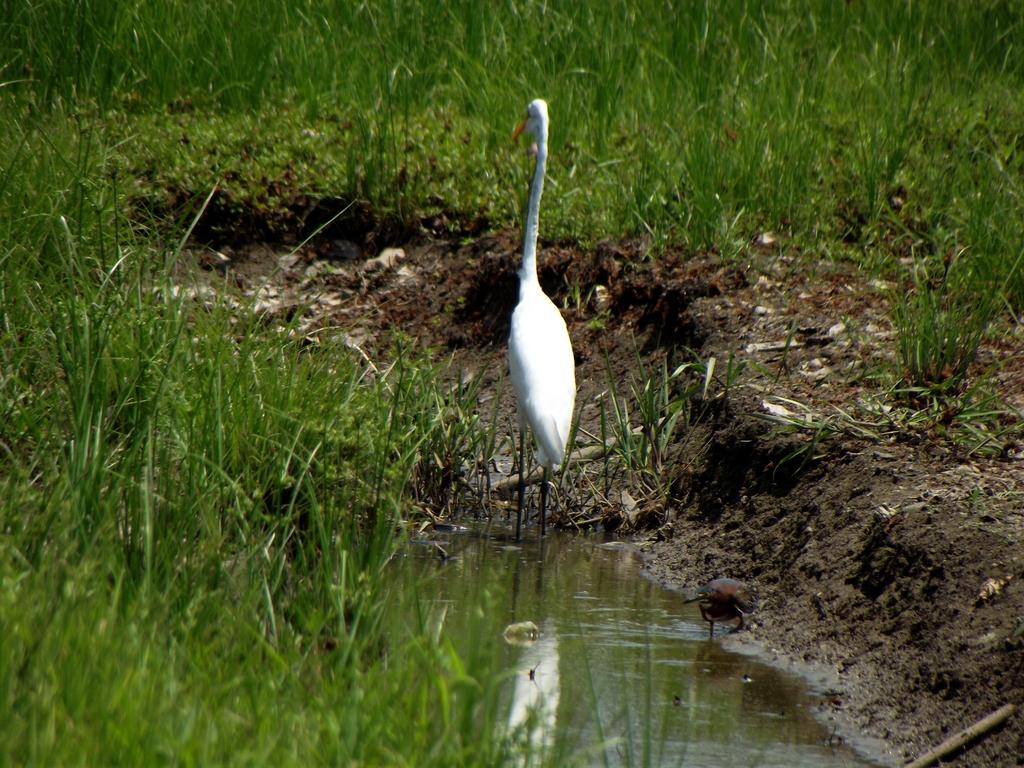What type of animal can be seen in the water in the image? There is a bird in the water in the image. What type of vegetation is visible on the ground? There is grass visible on the ground. Where is the fire located in the image? There is no fire present in the image. What type of transportation can be seen on the railway in the image? There is no railway or transportation present in the image. 